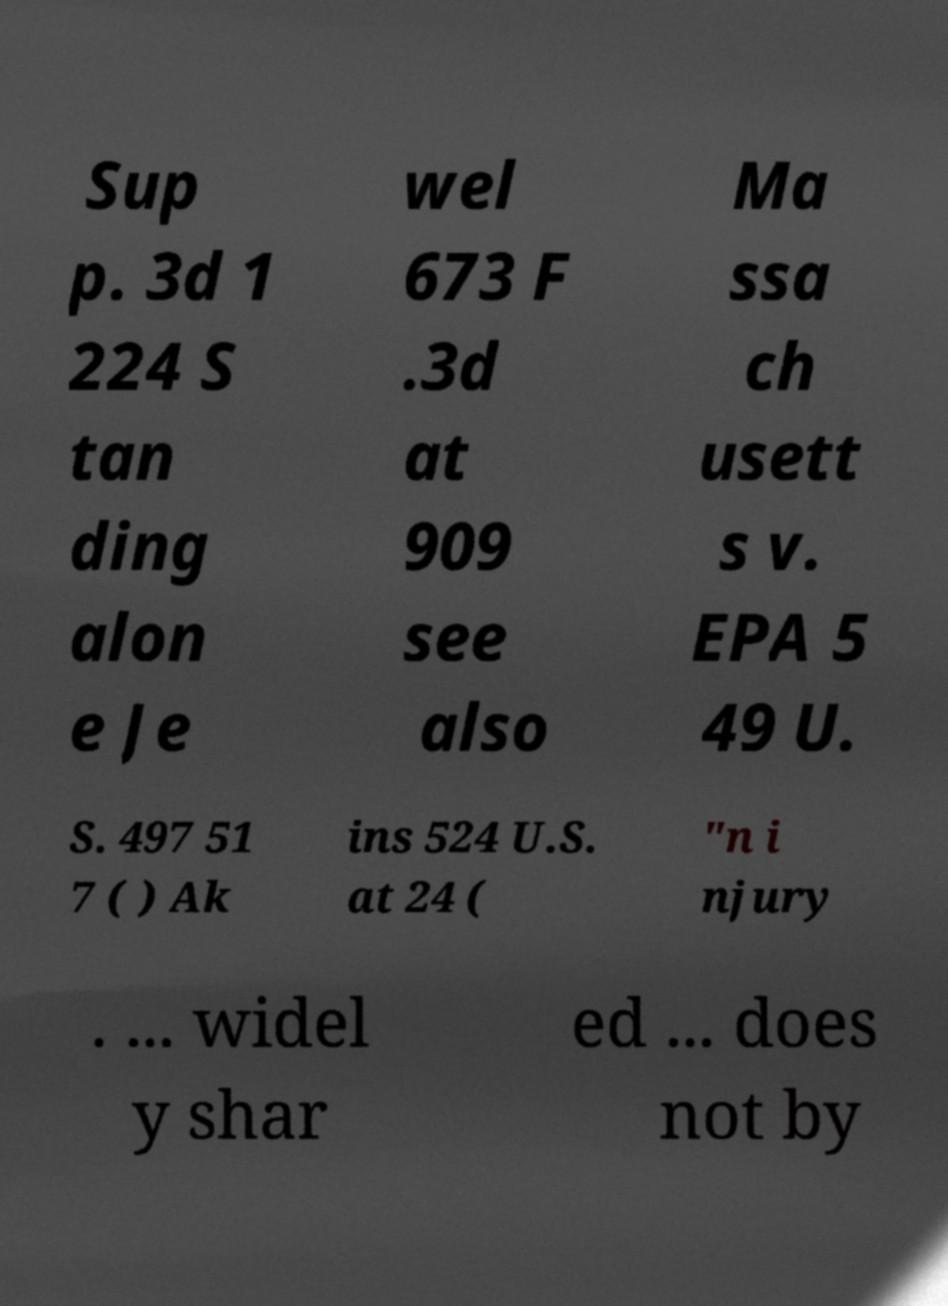There's text embedded in this image that I need extracted. Can you transcribe it verbatim? Sup p. 3d 1 224 S tan ding alon e Je wel 673 F .3d at 909 see also Ma ssa ch usett s v. EPA 5 49 U. S. 497 51 7 ( ) Ak ins 524 U.S. at 24 ( "n i njury . ... widel y shar ed ... does not by 